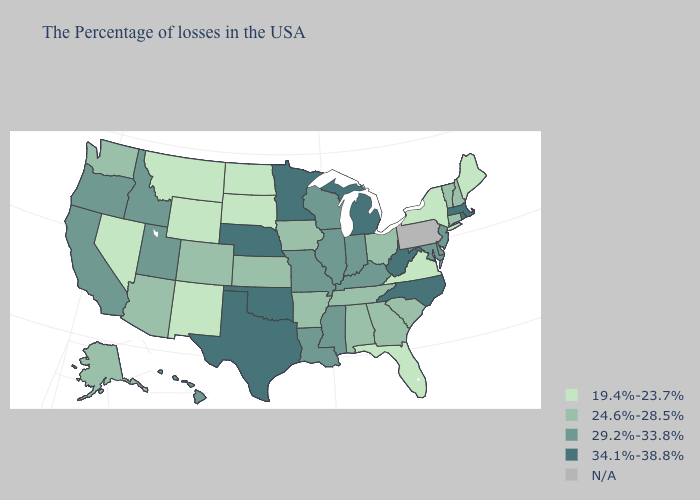Which states have the lowest value in the South?
Be succinct. Virginia, Florida. Name the states that have a value in the range 24.6%-28.5%?
Concise answer only. New Hampshire, Vermont, Connecticut, South Carolina, Ohio, Georgia, Alabama, Tennessee, Arkansas, Iowa, Kansas, Colorado, Arizona, Washington, Alaska. Name the states that have a value in the range 29.2%-33.8%?
Keep it brief. New Jersey, Delaware, Maryland, Kentucky, Indiana, Wisconsin, Illinois, Mississippi, Louisiana, Missouri, Utah, Idaho, California, Oregon, Hawaii. How many symbols are there in the legend?
Be succinct. 5. Which states have the highest value in the USA?
Quick response, please. Massachusetts, Rhode Island, North Carolina, West Virginia, Michigan, Minnesota, Nebraska, Oklahoma, Texas. Does the first symbol in the legend represent the smallest category?
Quick response, please. Yes. What is the value of Massachusetts?
Be succinct. 34.1%-38.8%. Name the states that have a value in the range N/A?
Answer briefly. Pennsylvania. Name the states that have a value in the range N/A?
Concise answer only. Pennsylvania. Does Idaho have the highest value in the West?
Quick response, please. Yes. How many symbols are there in the legend?
Give a very brief answer. 5. What is the lowest value in states that border Kansas?
Keep it brief. 24.6%-28.5%. What is the value of Alaska?
Concise answer only. 24.6%-28.5%. What is the value of Minnesota?
Concise answer only. 34.1%-38.8%. 